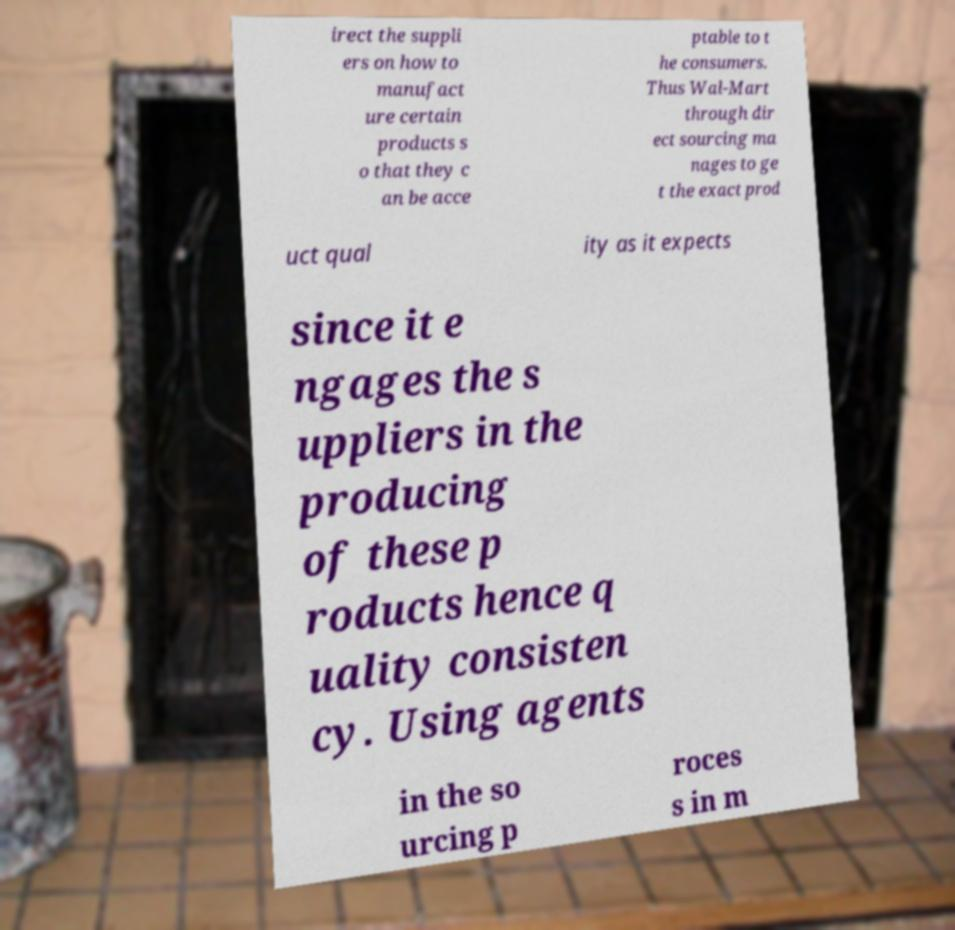Can you accurately transcribe the text from the provided image for me? irect the suppli ers on how to manufact ure certain products s o that they c an be acce ptable to t he consumers. Thus Wal-Mart through dir ect sourcing ma nages to ge t the exact prod uct qual ity as it expects since it e ngages the s uppliers in the producing of these p roducts hence q uality consisten cy. Using agents in the so urcing p roces s in m 